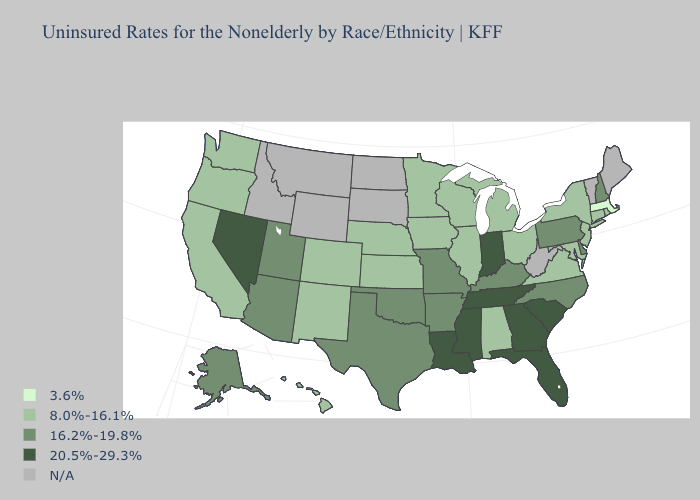Among the states that border Arkansas , which have the lowest value?
Be succinct. Missouri, Oklahoma, Texas. Name the states that have a value in the range 20.5%-29.3%?
Short answer required. Florida, Georgia, Indiana, Louisiana, Mississippi, Nevada, South Carolina, Tennessee. What is the lowest value in states that border Oklahoma?
Short answer required. 8.0%-16.1%. Name the states that have a value in the range 3.6%?
Concise answer only. Massachusetts. What is the value of Wyoming?
Write a very short answer. N/A. Name the states that have a value in the range 8.0%-16.1%?
Quick response, please. Alabama, California, Colorado, Connecticut, Hawaii, Illinois, Iowa, Kansas, Maryland, Michigan, Minnesota, Nebraska, New Jersey, New Mexico, New York, Ohio, Oregon, Rhode Island, Virginia, Washington, Wisconsin. Among the states that border New Hampshire , which have the highest value?
Quick response, please. Massachusetts. What is the lowest value in states that border Vermont?
Concise answer only. 3.6%. Does Ohio have the lowest value in the USA?
Give a very brief answer. No. Name the states that have a value in the range 16.2%-19.8%?
Short answer required. Alaska, Arizona, Arkansas, Delaware, Kentucky, Missouri, New Hampshire, North Carolina, Oklahoma, Pennsylvania, Texas, Utah. What is the value of Nebraska?
Quick response, please. 8.0%-16.1%. What is the highest value in states that border South Carolina?
Short answer required. 20.5%-29.3%. Name the states that have a value in the range 16.2%-19.8%?
Write a very short answer. Alaska, Arizona, Arkansas, Delaware, Kentucky, Missouri, New Hampshire, North Carolina, Oklahoma, Pennsylvania, Texas, Utah. Name the states that have a value in the range N/A?
Give a very brief answer. Idaho, Maine, Montana, North Dakota, South Dakota, Vermont, West Virginia, Wyoming. Name the states that have a value in the range 20.5%-29.3%?
Answer briefly. Florida, Georgia, Indiana, Louisiana, Mississippi, Nevada, South Carolina, Tennessee. 